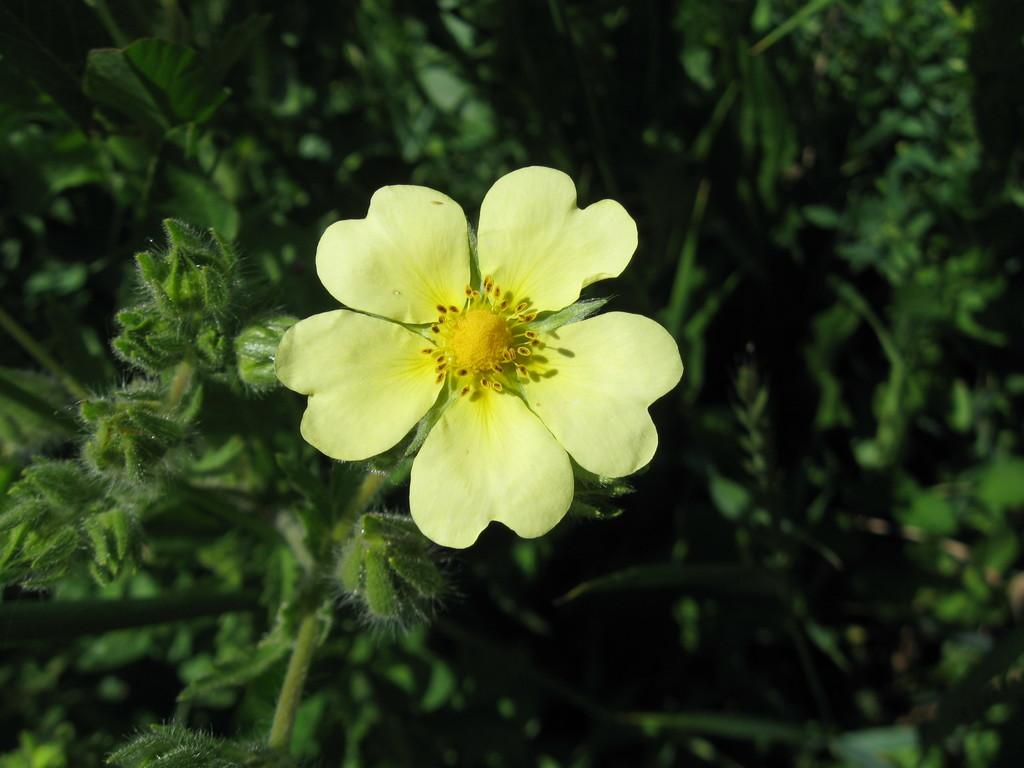What type of living organisms can be seen in the image? Plants can be seen in the image. Can you describe a specific flower among the plants? Yes, there is a yellow flower with petals in the image. Where are the children playing in the image? There are no children present in the image, so it is not possible to determine where they might be playing. 